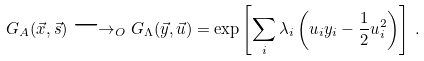<formula> <loc_0><loc_0><loc_500><loc_500>G _ { A } ( \vec { x } , \vec { s } ) \longrightarrow _ { O } G _ { \Lambda } ( \vec { y } , \vec { u } ) = \exp \left [ \sum _ { i } \lambda _ { i } \left ( u _ { i } y _ { i } - \frac { 1 } { 2 } u _ { i } ^ { 2 } \right ) \right ] \, .</formula> 